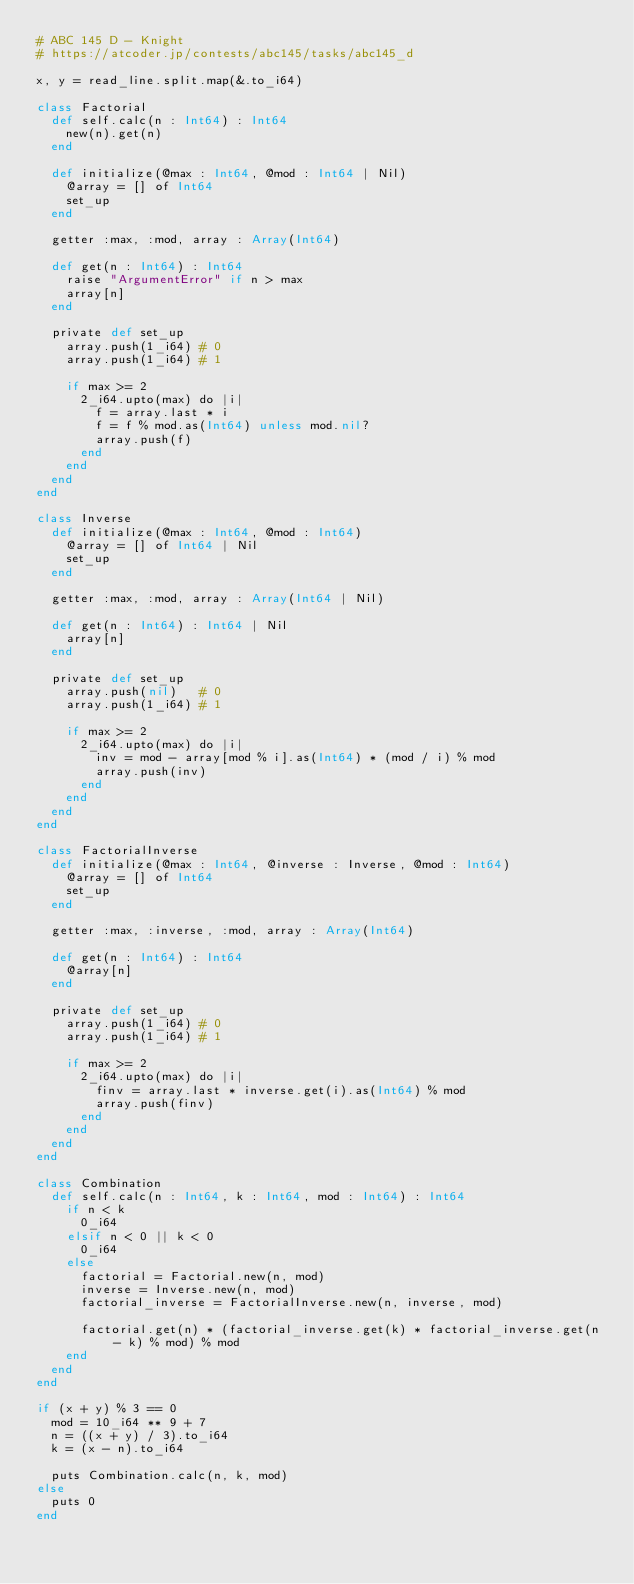Convert code to text. <code><loc_0><loc_0><loc_500><loc_500><_Crystal_># ABC 145 D - Knight
# https://atcoder.jp/contests/abc145/tasks/abc145_d

x, y = read_line.split.map(&.to_i64)

class Factorial
  def self.calc(n : Int64) : Int64
    new(n).get(n)
  end

  def initialize(@max : Int64, @mod : Int64 | Nil)
    @array = [] of Int64
    set_up
  end

  getter :max, :mod, array : Array(Int64)

  def get(n : Int64) : Int64
    raise "ArgumentError" if n > max
    array[n]
  end

  private def set_up
    array.push(1_i64) # 0
    array.push(1_i64) # 1

    if max >= 2
      2_i64.upto(max) do |i|
        f = array.last * i
        f = f % mod.as(Int64) unless mod.nil?
        array.push(f)
      end
    end
  end
end

class Inverse
  def initialize(@max : Int64, @mod : Int64)
    @array = [] of Int64 | Nil
    set_up
  end

  getter :max, :mod, array : Array(Int64 | Nil)

  def get(n : Int64) : Int64 | Nil
    array[n]
  end

  private def set_up
    array.push(nil)   # 0
    array.push(1_i64) # 1

    if max >= 2
      2_i64.upto(max) do |i|
        inv = mod - array[mod % i].as(Int64) * (mod / i) % mod
        array.push(inv)
      end
    end
  end
end

class FactorialInverse
  def initialize(@max : Int64, @inverse : Inverse, @mod : Int64)
    @array = [] of Int64
    set_up
  end

  getter :max, :inverse, :mod, array : Array(Int64)

  def get(n : Int64) : Int64
    @array[n]
  end

  private def set_up
    array.push(1_i64) # 0
    array.push(1_i64) # 1

    if max >= 2
      2_i64.upto(max) do |i|
        finv = array.last * inverse.get(i).as(Int64) % mod
        array.push(finv)
      end
    end
  end
end

class Combination
  def self.calc(n : Int64, k : Int64, mod : Int64) : Int64
    if n < k
      0_i64
    elsif n < 0 || k < 0
      0_i64
    else
      factorial = Factorial.new(n, mod)
      inverse = Inverse.new(n, mod)
      factorial_inverse = FactorialInverse.new(n, inverse, mod)

      factorial.get(n) * (factorial_inverse.get(k) * factorial_inverse.get(n - k) % mod) % mod
    end
  end
end

if (x + y) % 3 == 0
  mod = 10_i64 ** 9 + 7
  n = ((x + y) / 3).to_i64
  k = (x - n).to_i64

  puts Combination.calc(n, k, mod)
else
  puts 0
end
</code> 